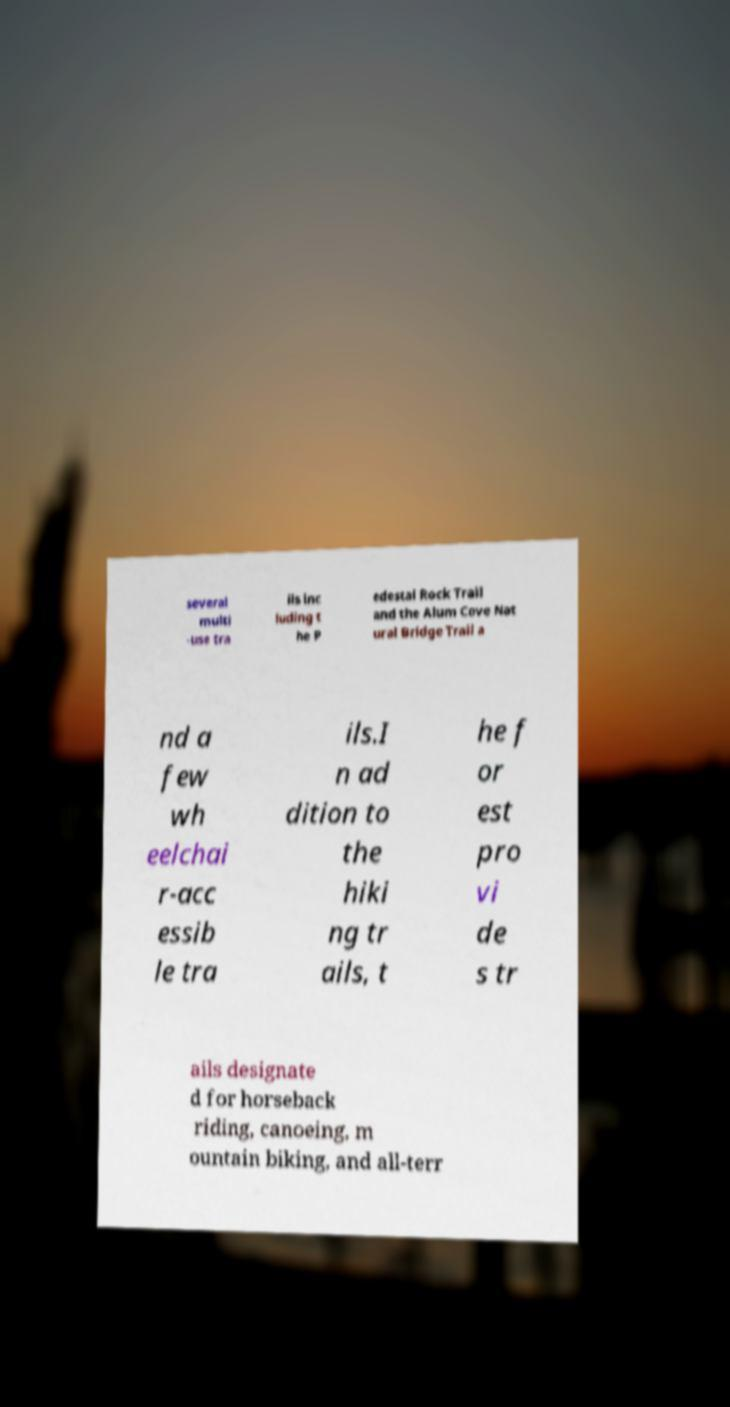Can you accurately transcribe the text from the provided image for me? several multi -use tra ils inc luding t he P edestal Rock Trail and the Alum Cove Nat ural Bridge Trail a nd a few wh eelchai r-acc essib le tra ils.I n ad dition to the hiki ng tr ails, t he f or est pro vi de s tr ails designate d for horseback riding, canoeing, m ountain biking, and all-terr 